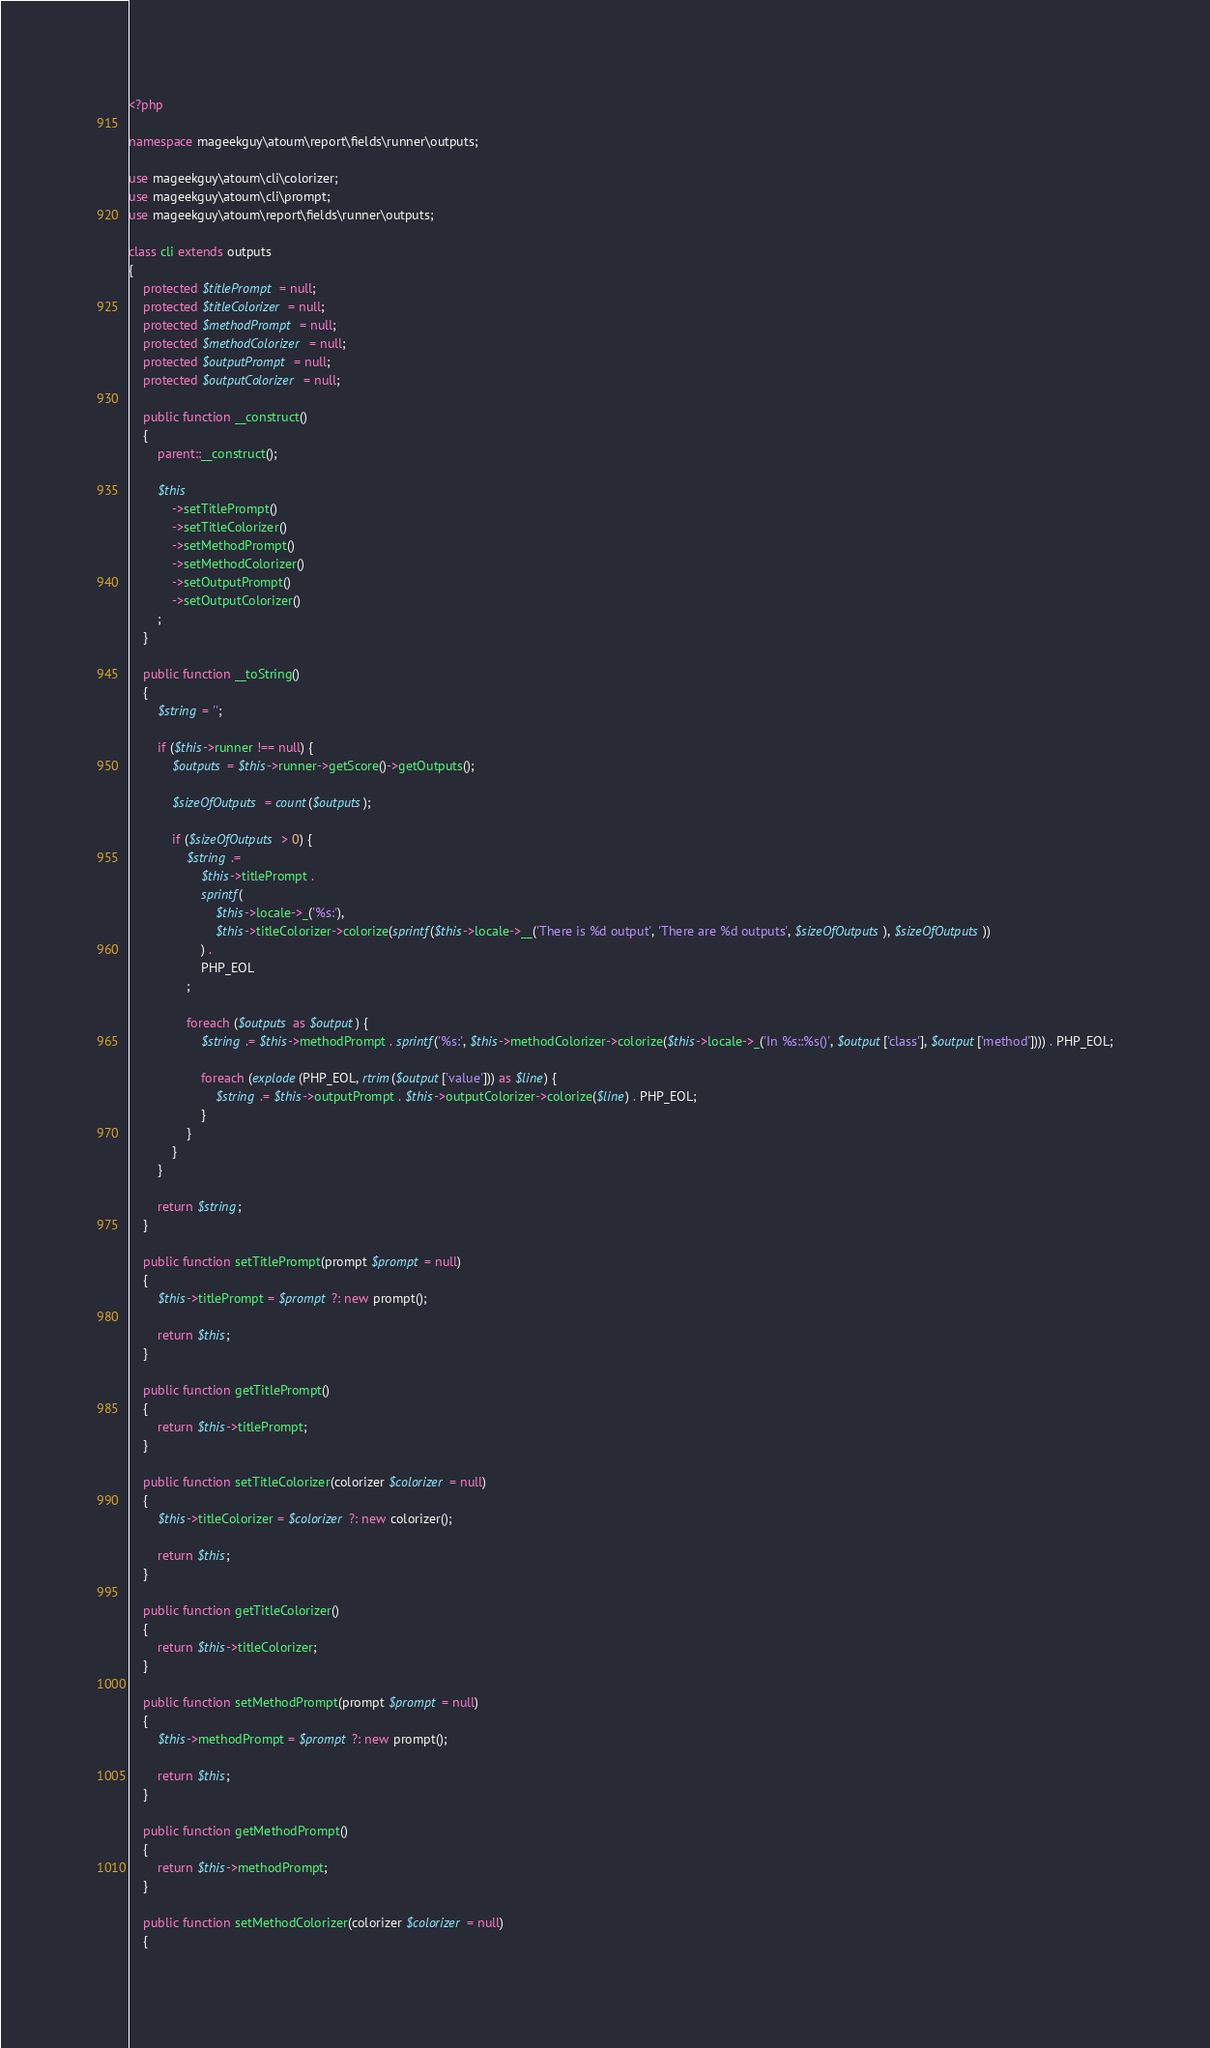Convert code to text. <code><loc_0><loc_0><loc_500><loc_500><_PHP_><?php

namespace mageekguy\atoum\report\fields\runner\outputs;

use mageekguy\atoum\cli\colorizer;
use mageekguy\atoum\cli\prompt;
use mageekguy\atoum\report\fields\runner\outputs;

class cli extends outputs
{
    protected $titlePrompt = null;
    protected $titleColorizer = null;
    protected $methodPrompt = null;
    protected $methodColorizer = null;
    protected $outputPrompt = null;
    protected $outputColorizer = null;

    public function __construct()
    {
        parent::__construct();

        $this
            ->setTitlePrompt()
            ->setTitleColorizer()
            ->setMethodPrompt()
            ->setMethodColorizer()
            ->setOutputPrompt()
            ->setOutputColorizer()
        ;
    }

    public function __toString()
    {
        $string = '';

        if ($this->runner !== null) {
            $outputs = $this->runner->getScore()->getOutputs();

            $sizeOfOutputs = count($outputs);

            if ($sizeOfOutputs > 0) {
                $string .=
                    $this->titlePrompt .
                    sprintf(
                        $this->locale->_('%s:'),
                        $this->titleColorizer->colorize(sprintf($this->locale->__('There is %d output', 'There are %d outputs', $sizeOfOutputs), $sizeOfOutputs))
                    ) .
                    PHP_EOL
                ;

                foreach ($outputs as $output) {
                    $string .= $this->methodPrompt . sprintf('%s:', $this->methodColorizer->colorize($this->locale->_('In %s::%s()', $output['class'], $output['method']))) . PHP_EOL;

                    foreach (explode(PHP_EOL, rtrim($output['value'])) as $line) {
                        $string .= $this->outputPrompt . $this->outputColorizer->colorize($line) . PHP_EOL;
                    }
                }
            }
        }

        return $string;
    }

    public function setTitlePrompt(prompt $prompt = null)
    {
        $this->titlePrompt = $prompt ?: new prompt();

        return $this;
    }

    public function getTitlePrompt()
    {
        return $this->titlePrompt;
    }

    public function setTitleColorizer(colorizer $colorizer = null)
    {
        $this->titleColorizer = $colorizer ?: new colorizer();

        return $this;
    }

    public function getTitleColorizer()
    {
        return $this->titleColorizer;
    }

    public function setMethodPrompt(prompt $prompt = null)
    {
        $this->methodPrompt = $prompt ?: new prompt();

        return $this;
    }

    public function getMethodPrompt()
    {
        return $this->methodPrompt;
    }

    public function setMethodColorizer(colorizer $colorizer = null)
    {</code> 